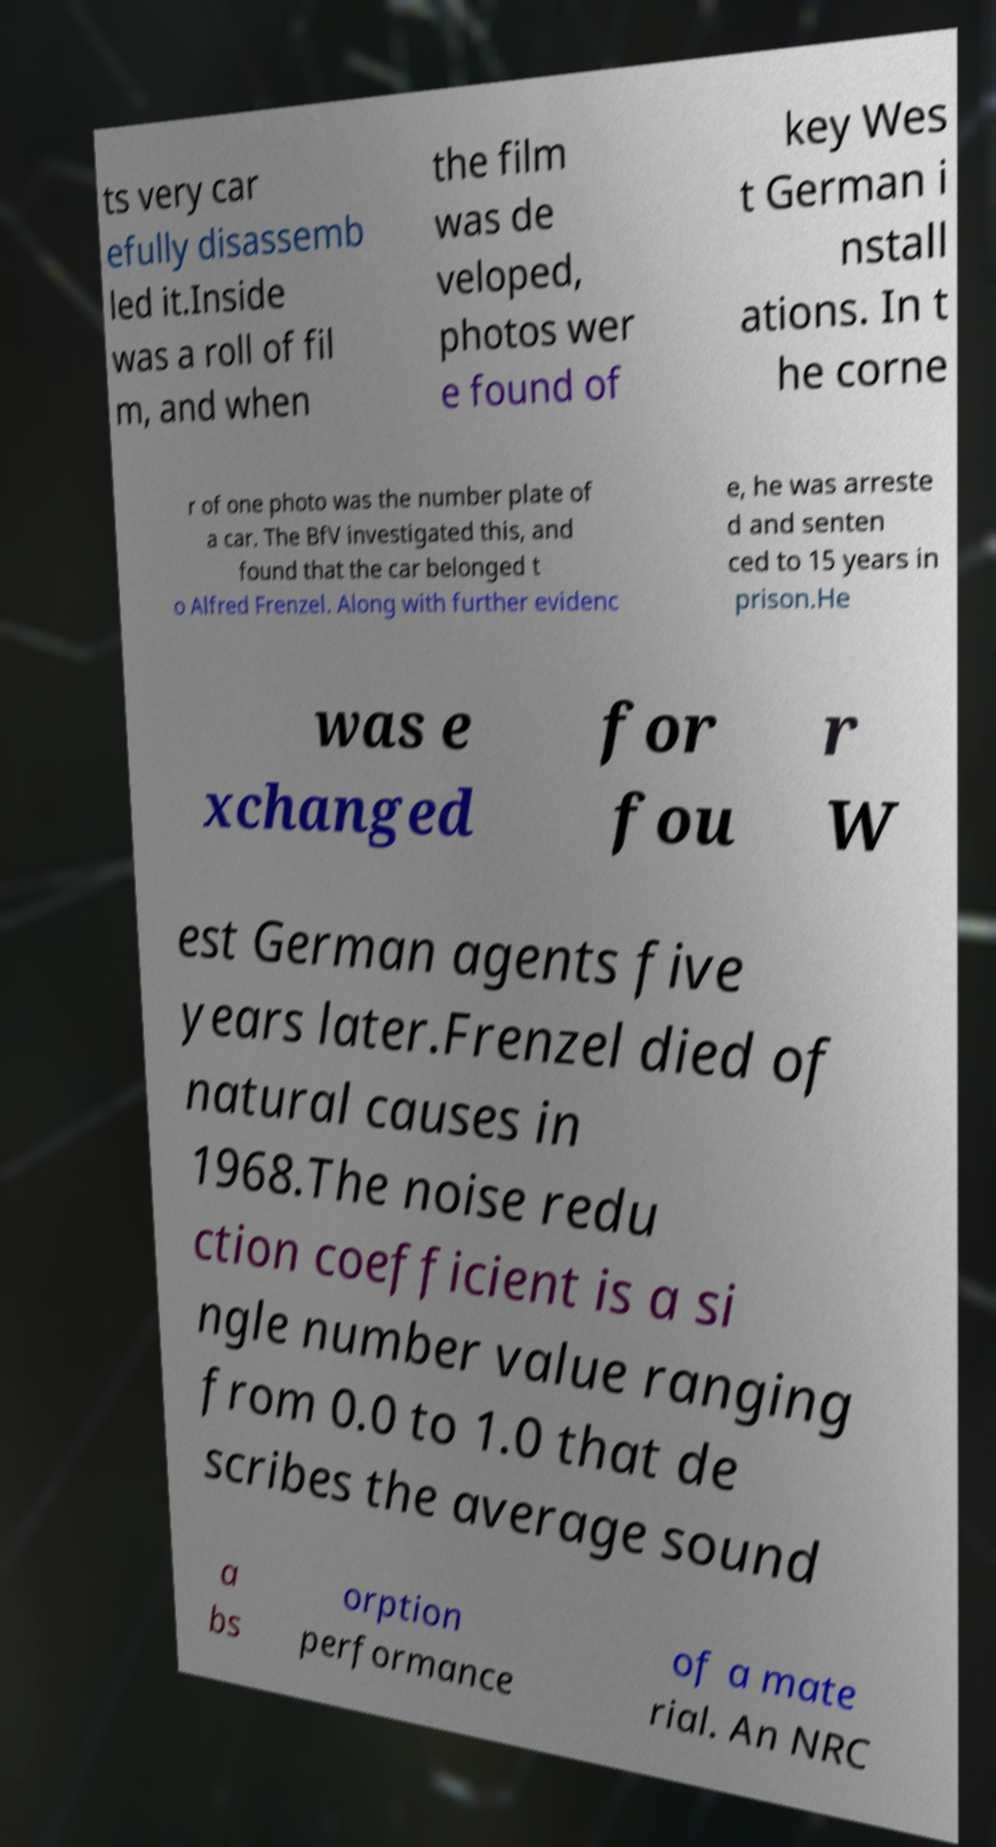Can you read and provide the text displayed in the image?This photo seems to have some interesting text. Can you extract and type it out for me? ts very car efully disassemb led it.Inside was a roll of fil m, and when the film was de veloped, photos wer e found of key Wes t German i nstall ations. In t he corne r of one photo was the number plate of a car. The BfV investigated this, and found that the car belonged t o Alfred Frenzel. Along with further evidenc e, he was arreste d and senten ced to 15 years in prison.He was e xchanged for fou r W est German agents five years later.Frenzel died of natural causes in 1968.The noise redu ction coefficient is a si ngle number value ranging from 0.0 to 1.0 that de scribes the average sound a bs orption performance of a mate rial. An NRC 